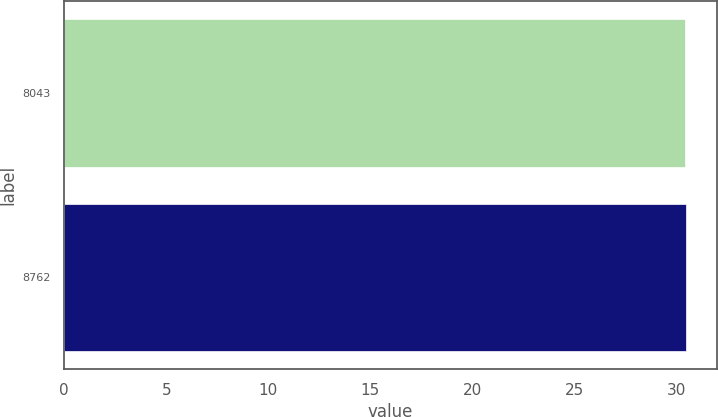Convert chart. <chart><loc_0><loc_0><loc_500><loc_500><bar_chart><fcel>8043<fcel>8762<nl><fcel>30.42<fcel>30.46<nl></chart> 